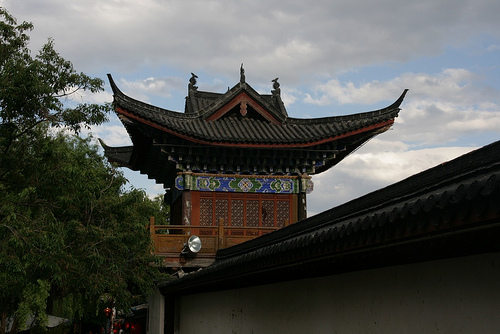<image>
Is there a sky behind the palace? Yes. From this viewpoint, the sky is positioned behind the palace, with the palace partially or fully occluding the sky. 